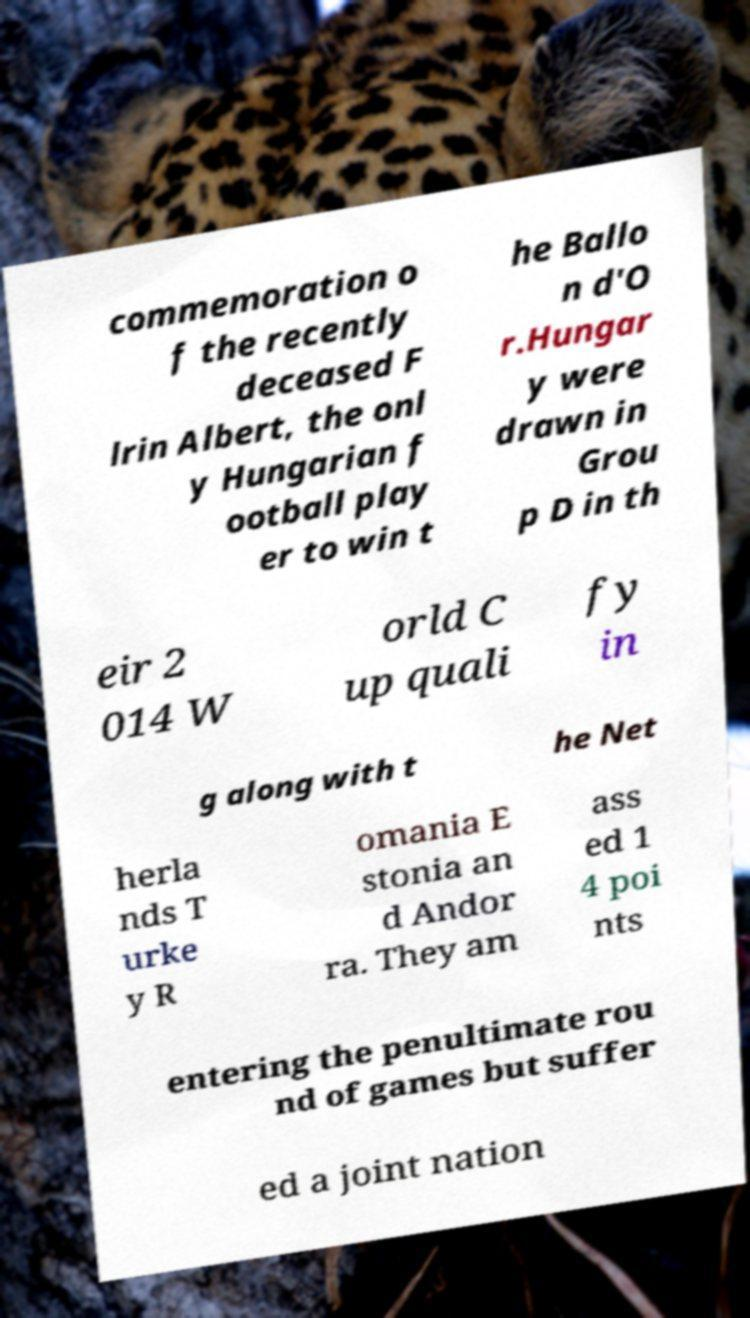Please identify and transcribe the text found in this image. commemoration o f the recently deceased F lrin Albert, the onl y Hungarian f ootball play er to win t he Ballo n d'O r.Hungar y were drawn in Grou p D in th eir 2 014 W orld C up quali fy in g along with t he Net herla nds T urke y R omania E stonia an d Andor ra. They am ass ed 1 4 poi nts entering the penultimate rou nd of games but suffer ed a joint nation 